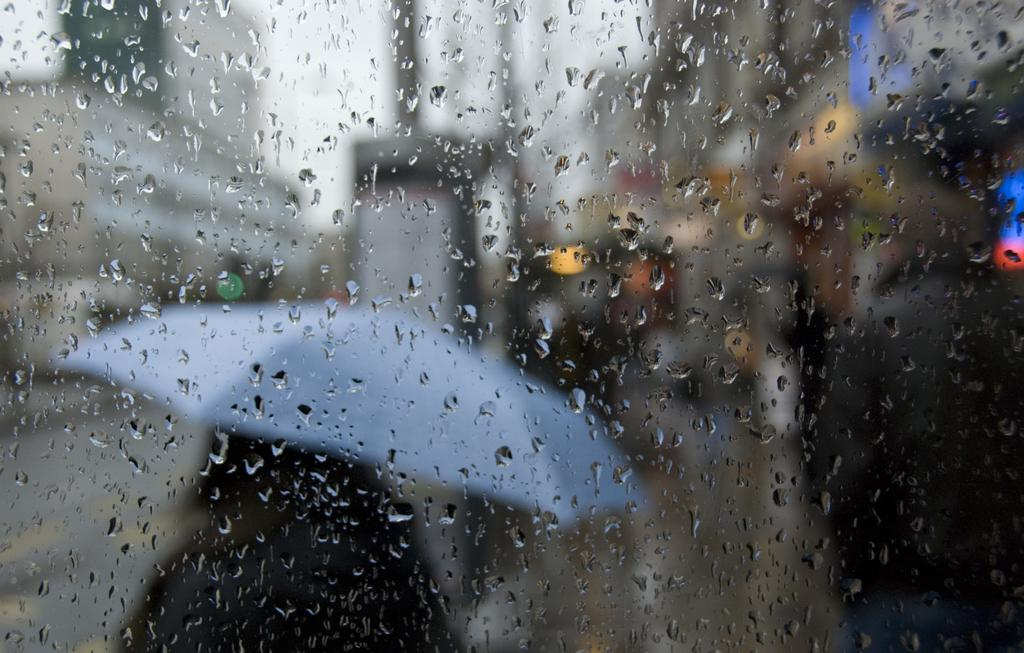What object can be seen in the image that is typically used for drinking? There is a glass in the image. What is present in the background of the image? There is an umbrella in the background of the image. What color is the umbrella? The umbrella is in light blue color. What part of the natural environment is visible in the background of the image? The sky is visible in the background of the image. What color is the sky in the image? The sky is in white color. Can you tell me how many goose feathers are visible on the glass in the image? There are no goose feathers visible on the glass in the image. What type of poison is being used to clean the umbrella in the image? There is no poison present in the image, and the umbrella is not being cleaned. 